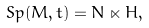Convert formula to latex. <formula><loc_0><loc_0><loc_500><loc_500>S p ( M , t ) = N \ltimes H ,</formula> 